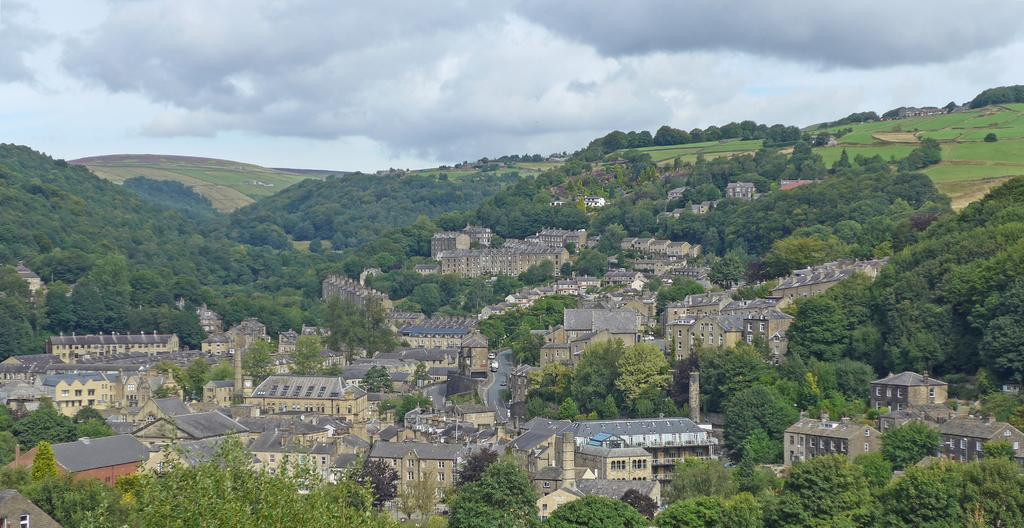What can be seen on the road in the image? There are vehicles on the road in the image. How are the buildings in the image colored? The buildings in the image are in gray and cream colors. What is the color of the trees in the image? The trees in the image are green. What is the color of the sky in the image? The sky in the image appears to be white. Where can the chalk be found in the image? There is no chalk present in the image. How many clovers are growing near the trees in the image? There are no clovers visible in the image; only trees are present. 